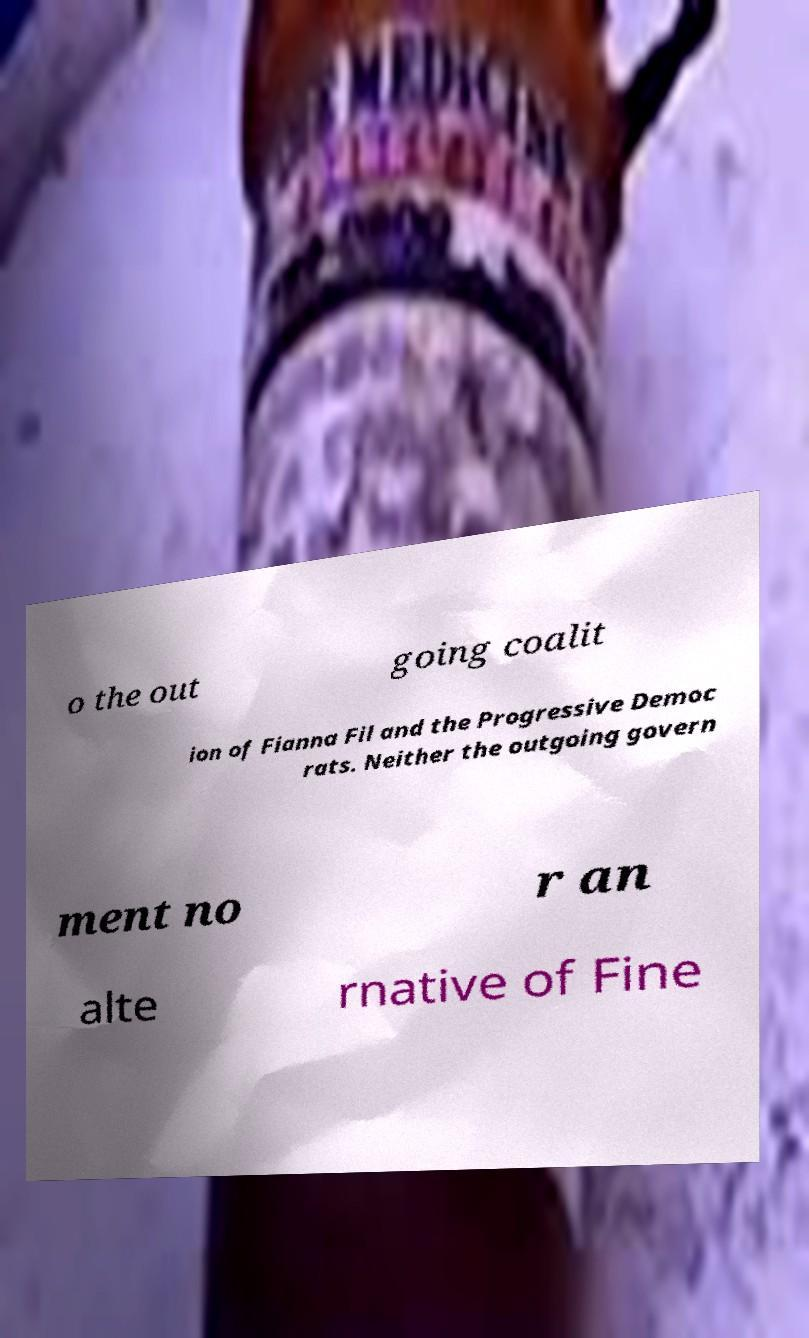What messages or text are displayed in this image? I need them in a readable, typed format. o the out going coalit ion of Fianna Fil and the Progressive Democ rats. Neither the outgoing govern ment no r an alte rnative of Fine 